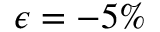Convert formula to latex. <formula><loc_0><loc_0><loc_500><loc_500>\epsilon = - 5 \%</formula> 